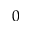<formula> <loc_0><loc_0><loc_500><loc_500>0</formula> 